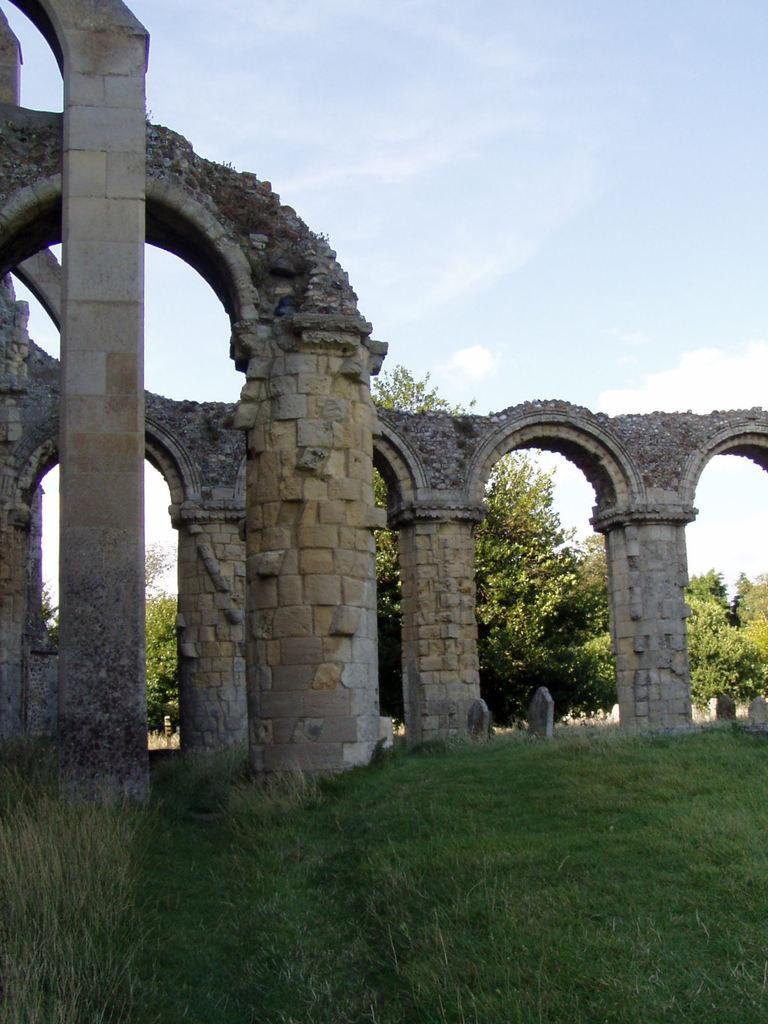What type of landscape is depicted in the image? There is a grassland in the image. What structures can be seen in the background of the image? There are pillars in the background of the image. What other natural elements are present in the background of the image? There are trees in the background of the image. What is visible in the sky in the image? The sky is visible in the background of the image. What type of fuel is being used by the ear in the image? There is no ear or fuel present in the image. 